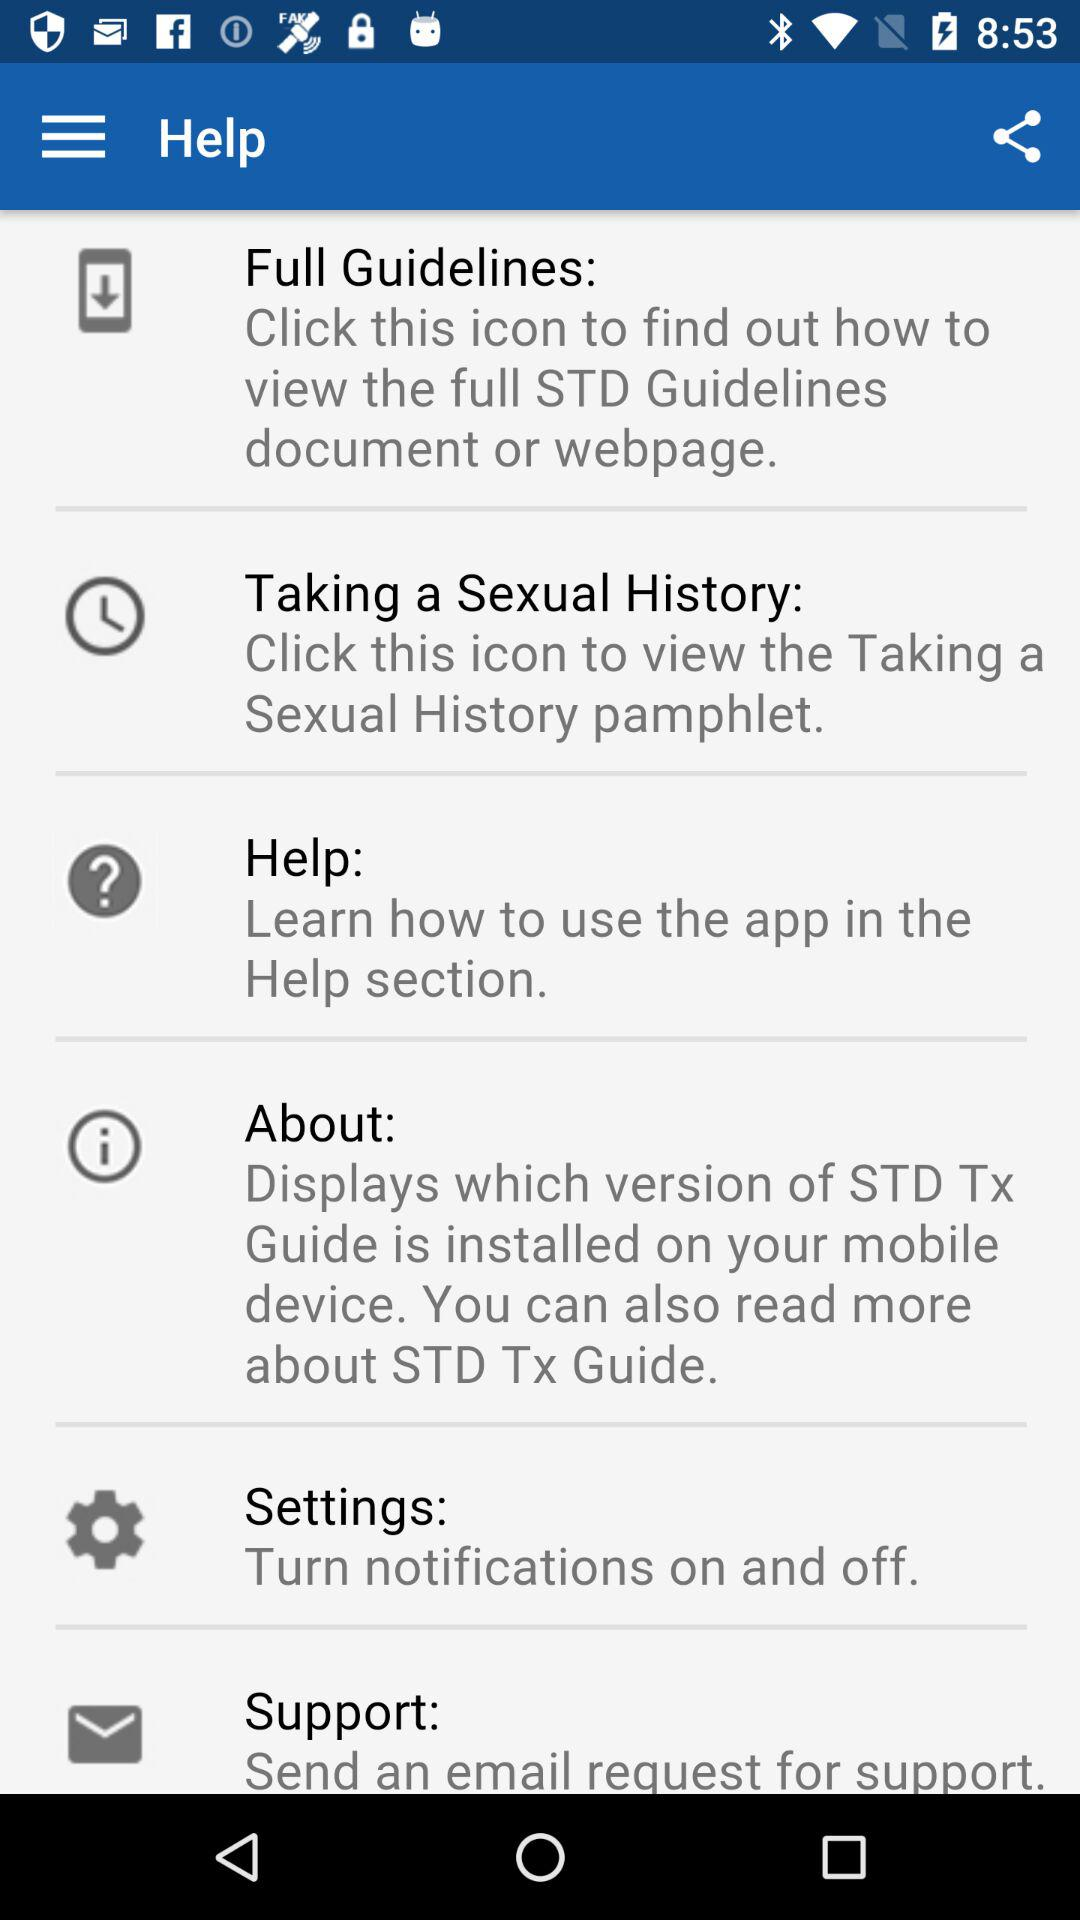How many items are in the menu?
Answer the question using a single word or phrase. 6 